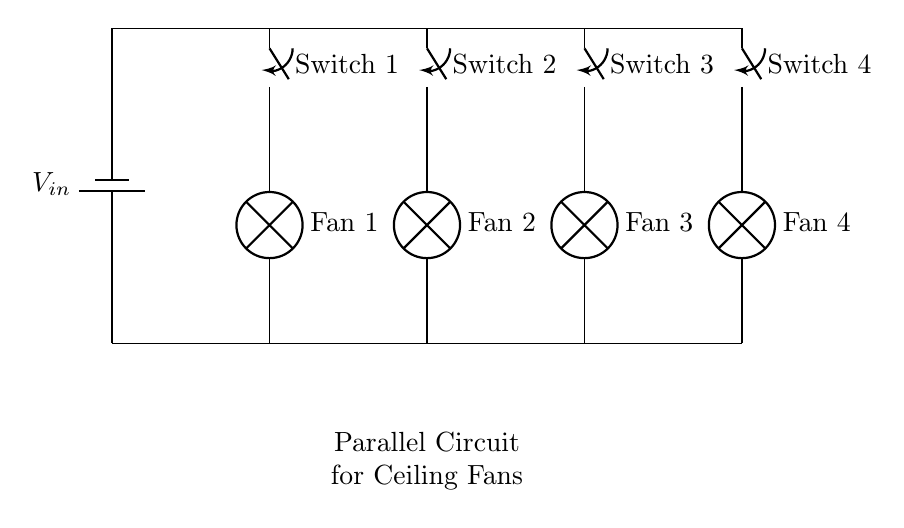What is the input voltage of this circuit? The input voltage is represented by the battery labeled V_in at the top of the circuit. The circuit uses this voltage as the source for the fans.
Answer: V_in How many ceiling fans are controlled in this circuit? There are four switches and lamps labeled as Fan 1, Fan 2, Fan 3, and Fan 4, indicating that four ceiling fans can be controlled by this parallel circuit.
Answer: Four What type of circuit is represented here? The parallel arrangement of the switches and fans is characteristic of a parallel circuit, where each fan operates independently while connected to the same voltage source.
Answer: Parallel If one fan is turned off, what happens to the others? In a parallel circuit, each component operates independently, so turning off one fan does not affect the operation of the other fans.
Answer: They remain on Which component is responsible for switching the fans on and off? The switches labeled Switch 1, Switch 2, Switch 3, and Switch 4 are responsible for controlling the power to their respective fans by allowing or interrupting the current flow.
Answer: Switches What is the lowest point in this circuit where components connect to the ground? The lowest points where all fans and switches connect is indicated at the bottom of the circuit, where they are connected to the ground line of the circuit.
Answer: The ground 